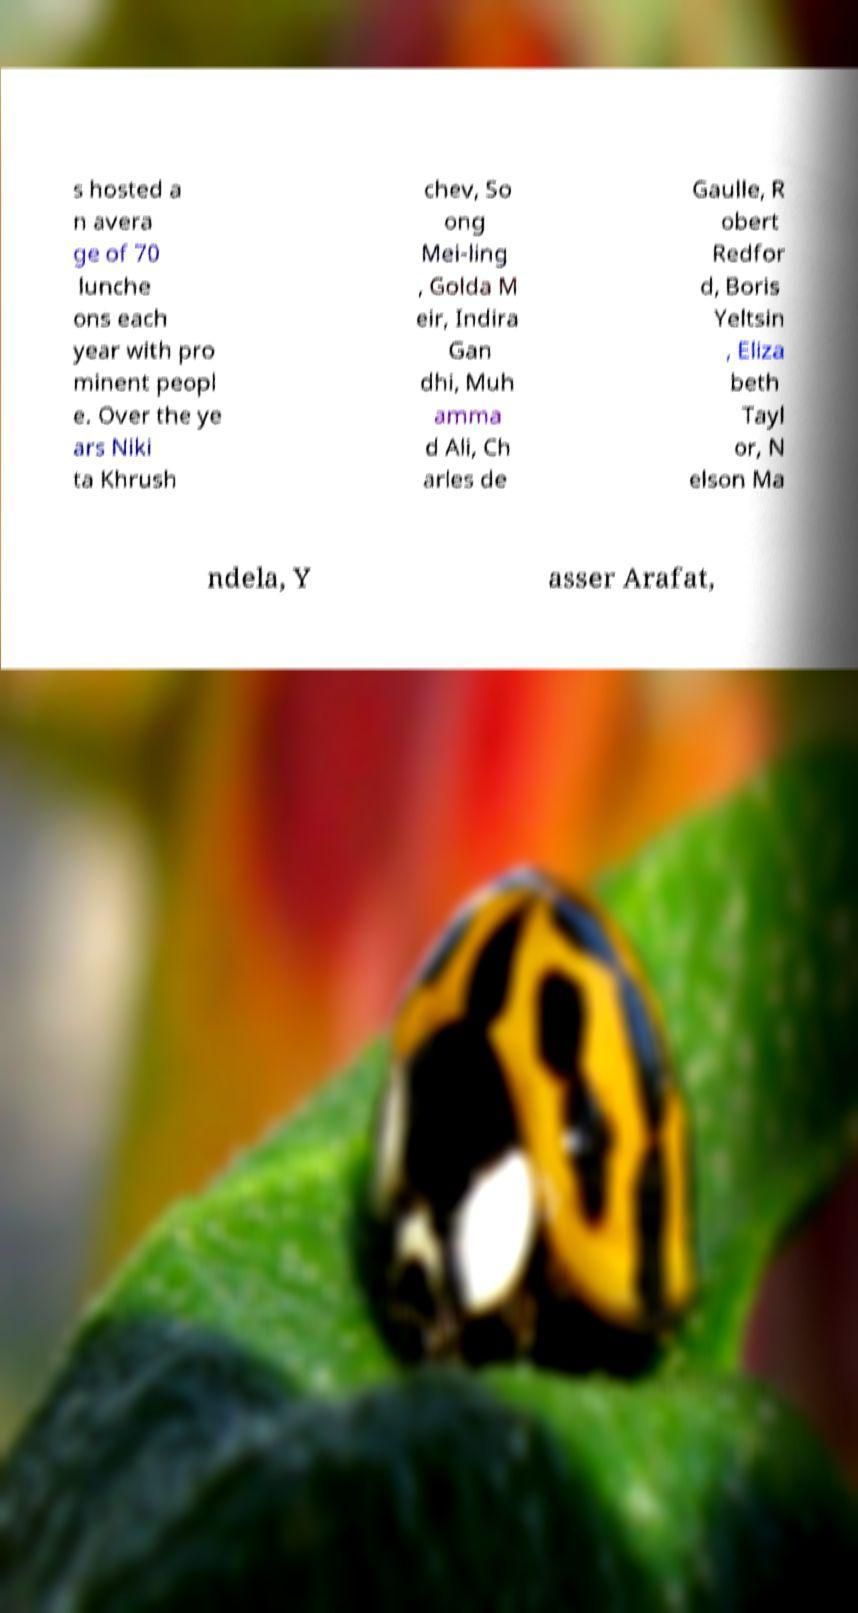Please identify and transcribe the text found in this image. s hosted a n avera ge of 70 lunche ons each year with pro minent peopl e. Over the ye ars Niki ta Khrush chev, So ong Mei-ling , Golda M eir, Indira Gan dhi, Muh amma d Ali, Ch arles de Gaulle, R obert Redfor d, Boris Yeltsin , Eliza beth Tayl or, N elson Ma ndela, Y asser Arafat, 